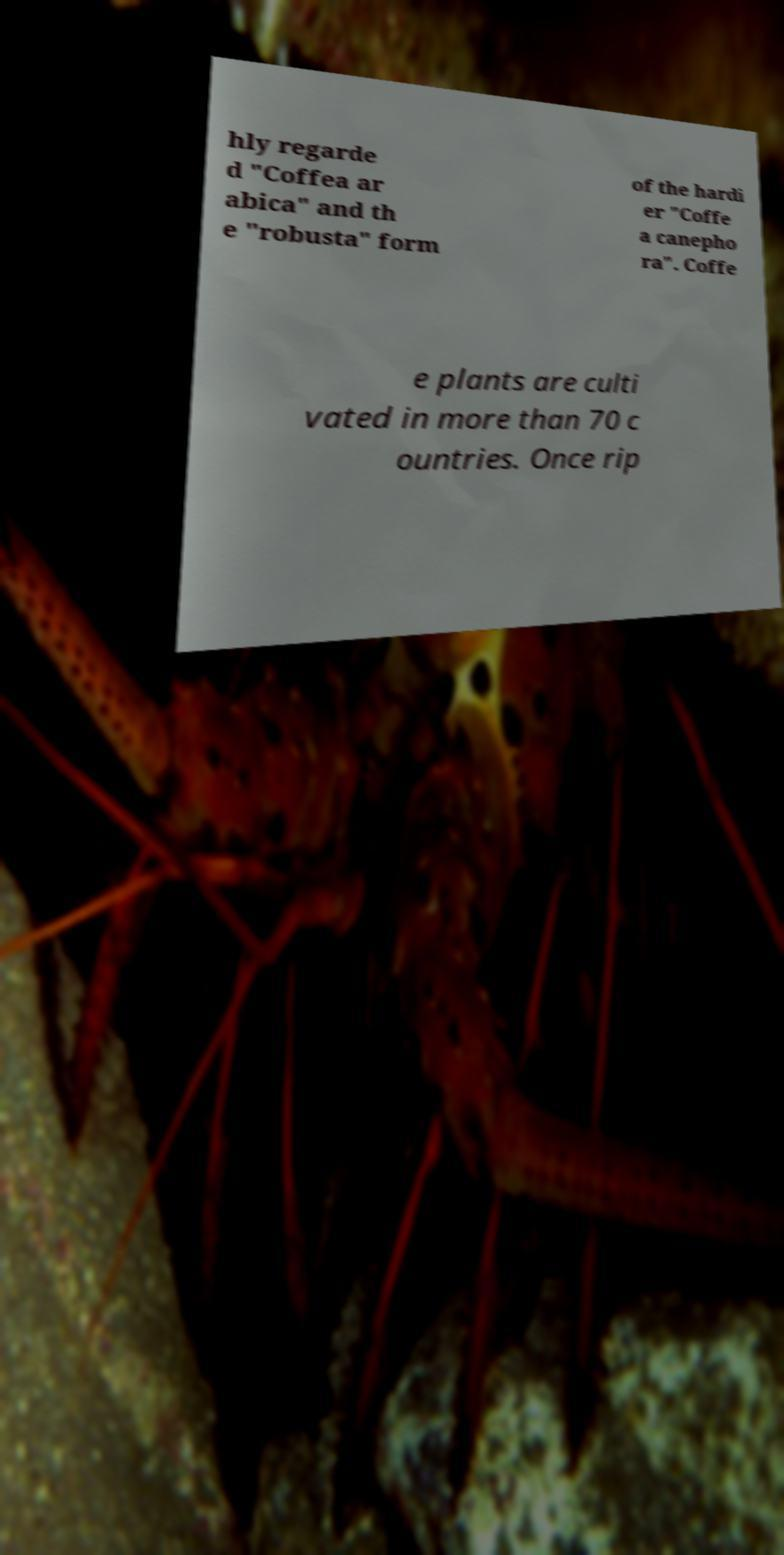I need the written content from this picture converted into text. Can you do that? hly regarde d "Coffea ar abica" and th e "robusta" form of the hardi er "Coffe a canepho ra". Coffe e plants are culti vated in more than 70 c ountries. Once rip 